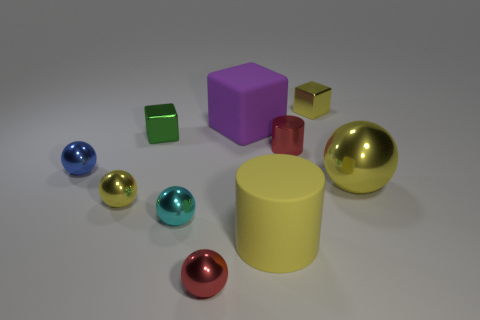There is a small object that is the same color as the shiny cylinder; what shape is it?
Make the answer very short. Sphere. How many cylinders are either large yellow metal objects or small gray shiny things?
Provide a succinct answer. 0. Does the cyan object have the same size as the red metal thing in front of the cyan sphere?
Keep it short and to the point. Yes. Is the number of rubber objects behind the yellow matte cylinder greater than the number of small yellow metallic blocks?
Offer a very short reply. No. The yellow thing that is made of the same material as the large cube is what size?
Make the answer very short. Large. Are there any large rubber cubes that have the same color as the large ball?
Your response must be concise. No. What number of objects are either small metal objects or tiny shiny cubes that are on the right side of the red shiny ball?
Provide a short and direct response. 7. Are there more large green matte balls than tiny blue metal balls?
Provide a succinct answer. No. The shiny block that is the same color as the matte cylinder is what size?
Give a very brief answer. Small. Is there a small yellow cube made of the same material as the big yellow ball?
Your answer should be very brief. Yes. 